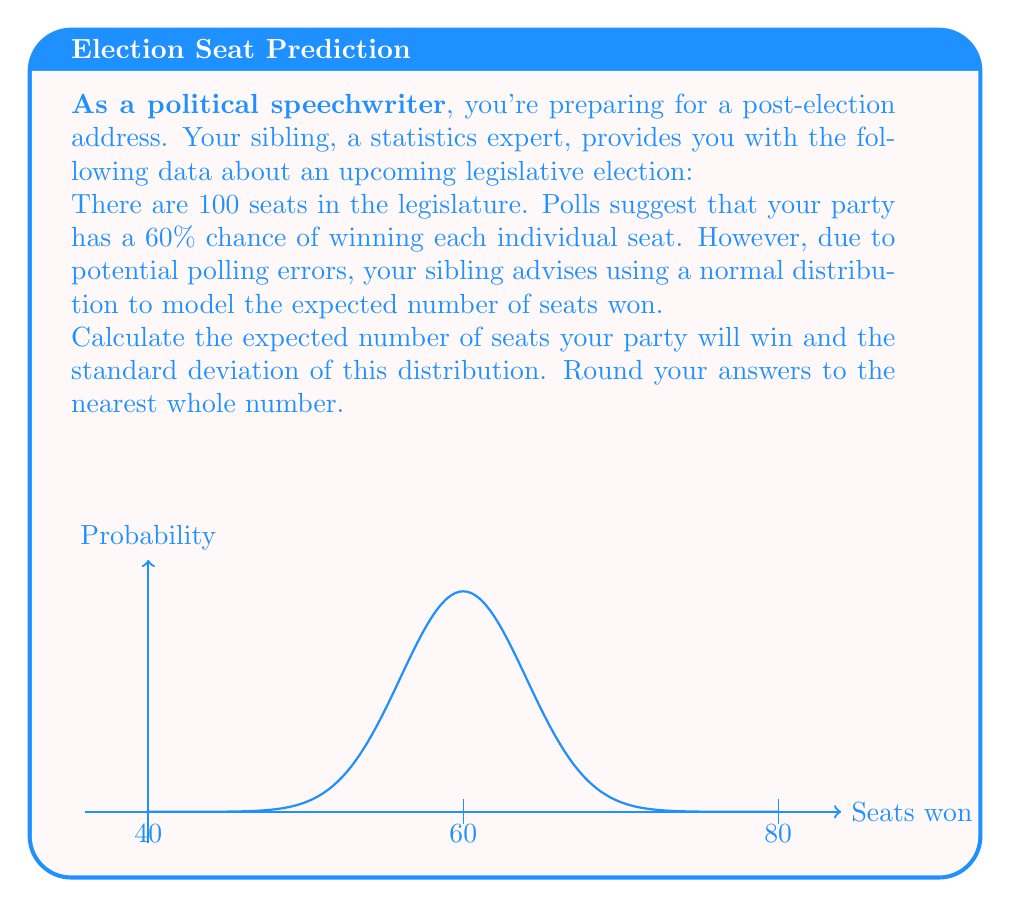Solve this math problem. Let's approach this step-by-step:

1) First, we need to identify the parameters of our binomial distribution:
   - $n$ (number of trials) = 100 (total seats)
   - $p$ (probability of success) = 0.60 (60% chance of winning each seat)

2) For a binomial distribution, the expected value (mean) is given by:
   $\mu = np = 100 \times 0.60 = 60$

3) The variance of a binomial distribution is given by:
   $\sigma^2 = np(1-p) = 100 \times 0.60 \times 0.40 = 24$

4) The standard deviation is the square root of the variance:
   $\sigma = \sqrt{24} \approx 4.90$

5) Rounding to the nearest whole number:
   Expected number of seats: 60
   Standard deviation: 5

Note: The normal distribution is a good approximation for the binomial distribution when $n$ is large and $p$ is not too close to 0 or 1, which is the case here. The normal distribution with $\mu = 60$ and $\sigma = 5$ closely approximates our binomial distribution.
Answer: 60 seats; 5 seat standard deviation 